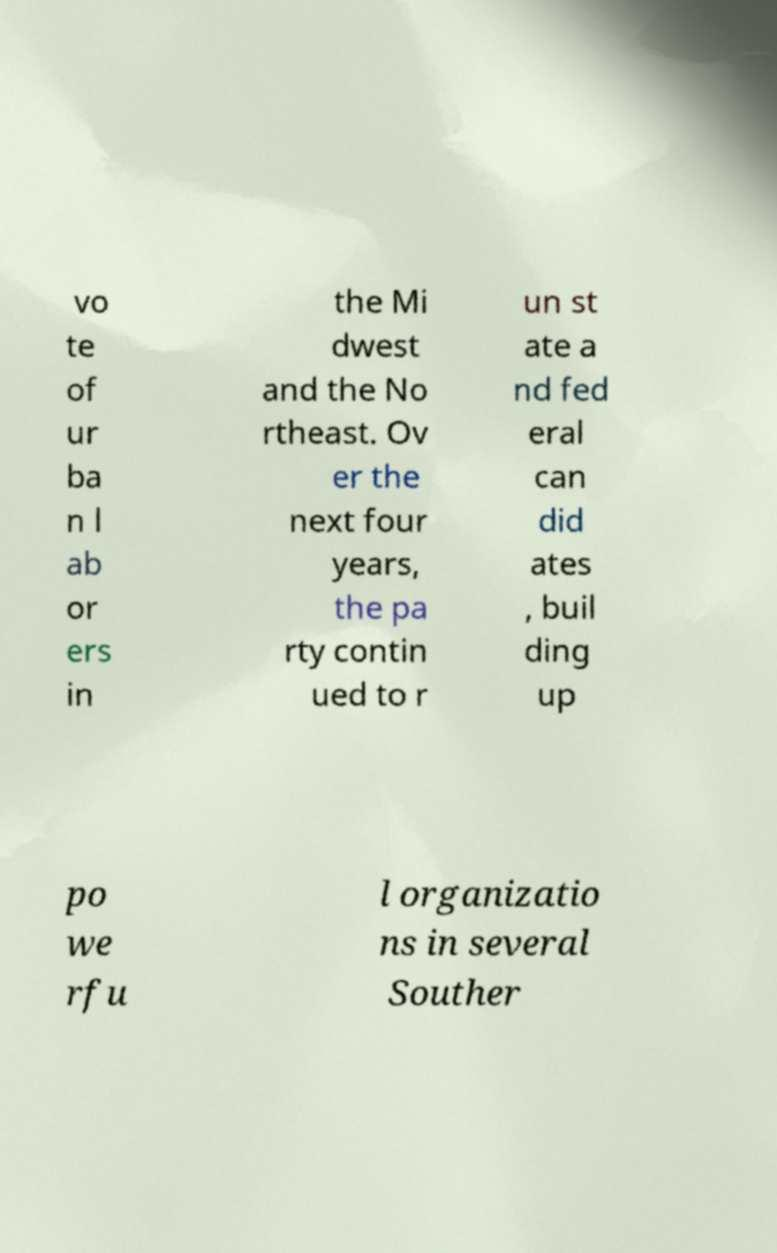What messages or text are displayed in this image? I need them in a readable, typed format. vo te of ur ba n l ab or ers in the Mi dwest and the No rtheast. Ov er the next four years, the pa rty contin ued to r un st ate a nd fed eral can did ates , buil ding up po we rfu l organizatio ns in several Souther 